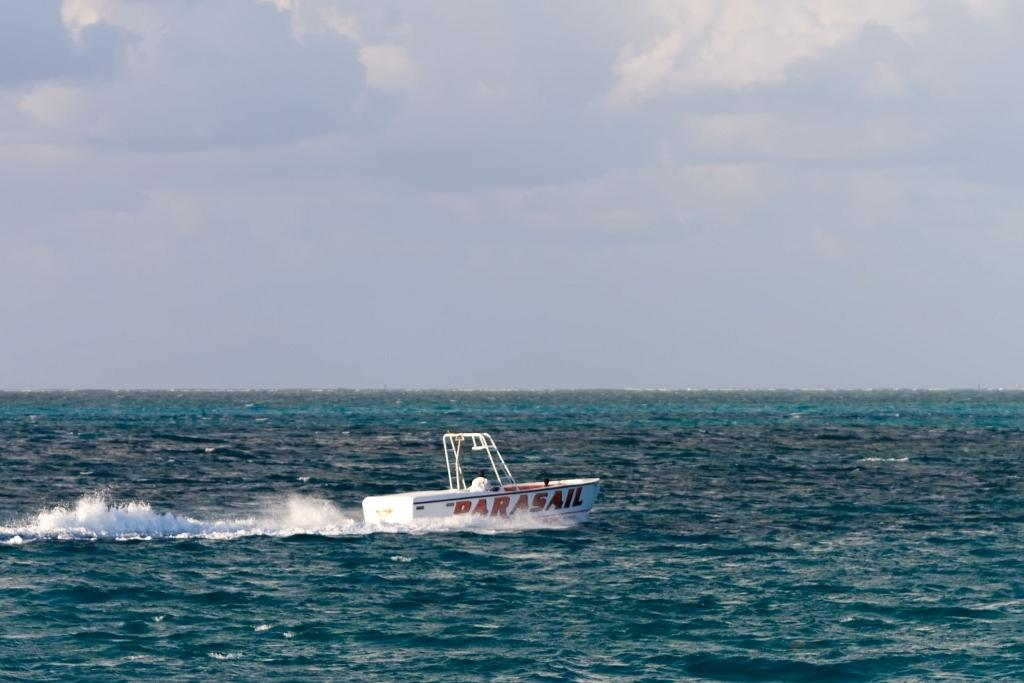What is the main subject of the image? The main subject of the image is people in a boat. What is the setting of the image? The setting of the image is on water, as there is water visible at the bottom of the image. What can be seen in the sky in the image? There are clouds in the sky at the top of the image. How many legs can be seen in the image? There is no specific information about legs in the image, as it primarily features people in a boat and the surrounding environment. 